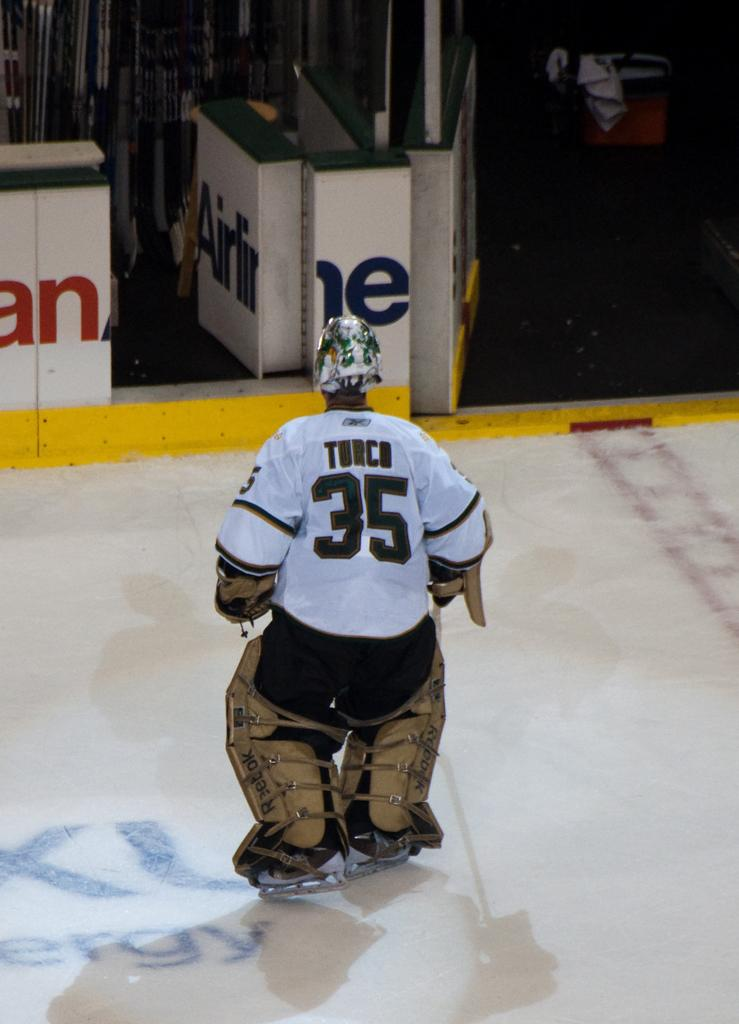Who or what is the main subject in the center of the image? There is a person in the center of the image. What can be seen in the background of the image? There are boards and some objects visible in the background of the image. How many card games are being played on the stove in the image? There is no stove or card games present in the image. Can you spot any ladybugs on the person in the image? There are no ladybugs visible on the person in the image. 